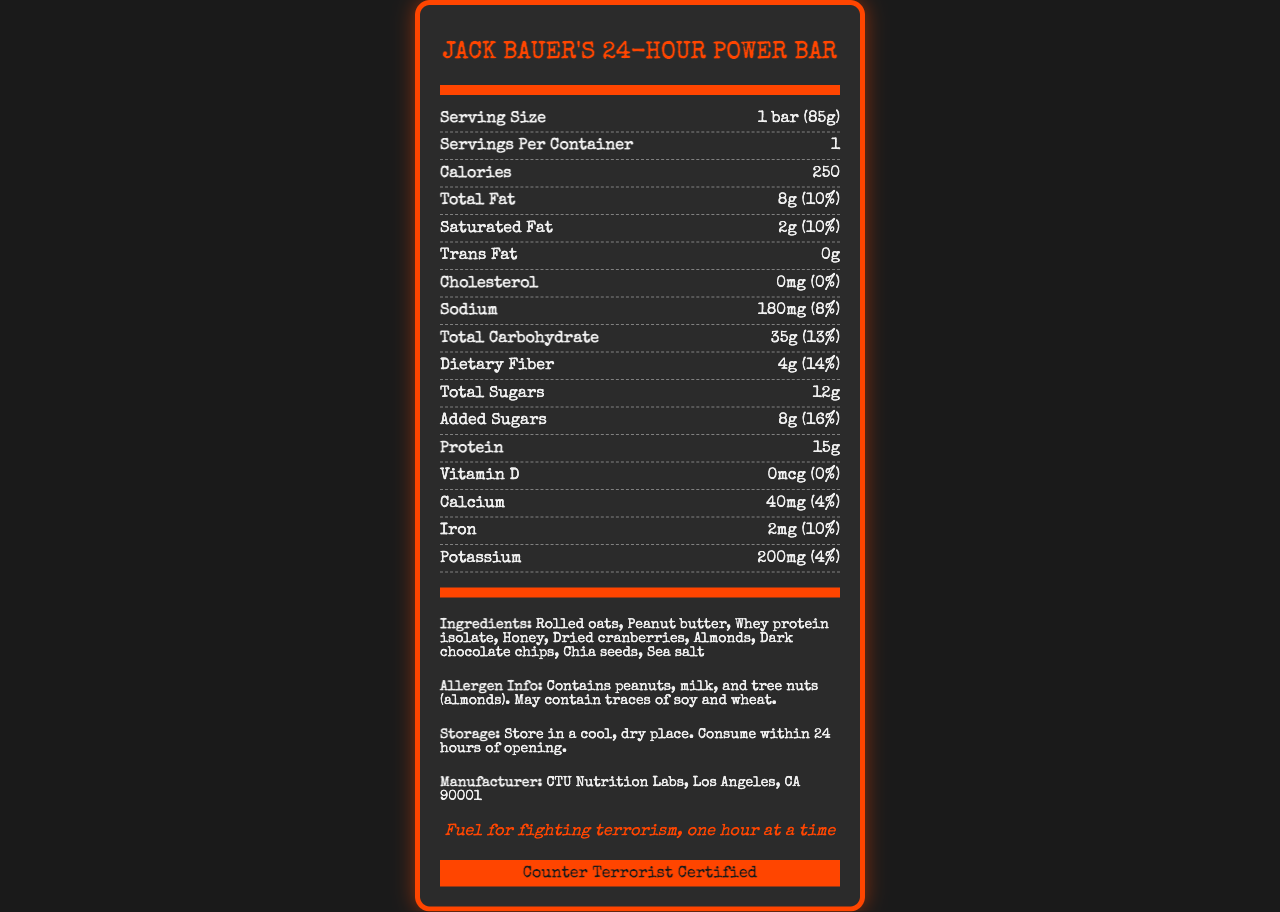what is the serving size of Jack Bauer's 24-Hour Power Bar? The serving size is listed in the nutrition facts section as "Serving Size: 1 bar (85g)".
Answer: 1 bar (85g) how many calories does one serving contain? The document specifies that one bar (serving size) contains 250 calories.
Answer: 250 how much total fat is in one bar? The total fat content is listed as 8g in the nutrition facts section.
Answer: 8g what is the daily value percentage of dietary fiber in the bar? The daily value percentage for dietary fiber is shown as 14%.
Answer: 14% what allergens does the bar contain? The allergen information section specifies that the bar contains peanuts, milk, and tree nuts (almonds).
Answer: peanuts, milk, and tree nuts (almonds) which of the following ingredients is not included in Jack Bauer's 24-Hour Power Bar? A. Honey B. Sea salt C. Coconut Coconut is not listed among the ingredients, while honey and sea salt are.
Answer: C what is the daily value percentage of added sugars in the bar? A. 8% B. 16% C. 10% The document lists added sugars as having a daily value of 16%.
Answer: B does the bar contain any trans fat? The nutrition facts show 0g of trans fat, meaning the bar contains no trans fat.
Answer: No is Jack Bauer's 24-Hour Power Bar Counter Terrorist Certified? The document includes a statement that the bar is "Counter Terrorist Certified".
Answer: Yes summarize the main nutritional attributes of Jack Bauer's 24-Hour Power Bar. The summary covers the key nutritional aspects including calories, fats, proteins, carbohydrates, fibers, sugars, and allergen information, adding that it is counter-terrorist certified.
Answer: Jack Bauer's 24-Hour Power Bar has 250 calories per bar (85g), with 8g of total fat, 15g of protein, and significant amounts of carbohydrates and fiber. It contains added sugars and has no trans fat or cholesterol. The bar is counter-terrorist certified and contains allergens such as peanuts, milk, and almonds. what is the barcode number on the packaging? The barcode number is not provided in the document, so this information cannot be determined.
Answer: Cannot be determined 